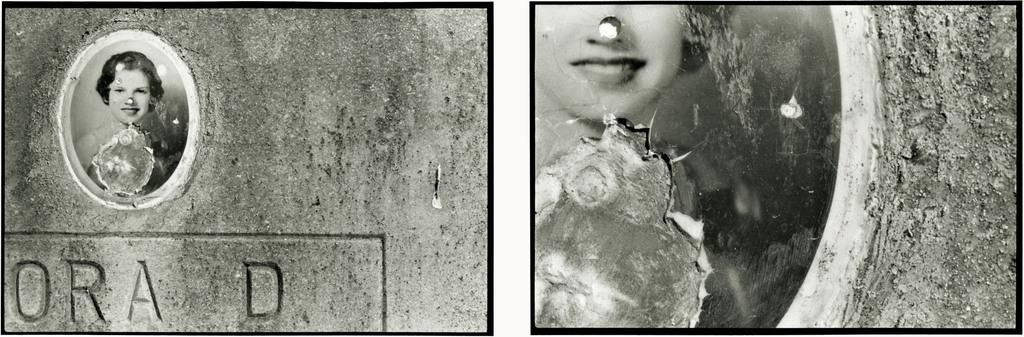What is the main subject of the image? The main subject of the image is two collage photos of a girl. Can you describe the text in the image? There is text written on the bottom left side of the image. What is the color scheme of the image? The color of the image is black and white. What type of flame can be seen in the image? There is no flame present in the image. What song is being sung by the girl in the image? There is no indication of a song being sung in the image, as it only contains two collage photos of a girl and text. 